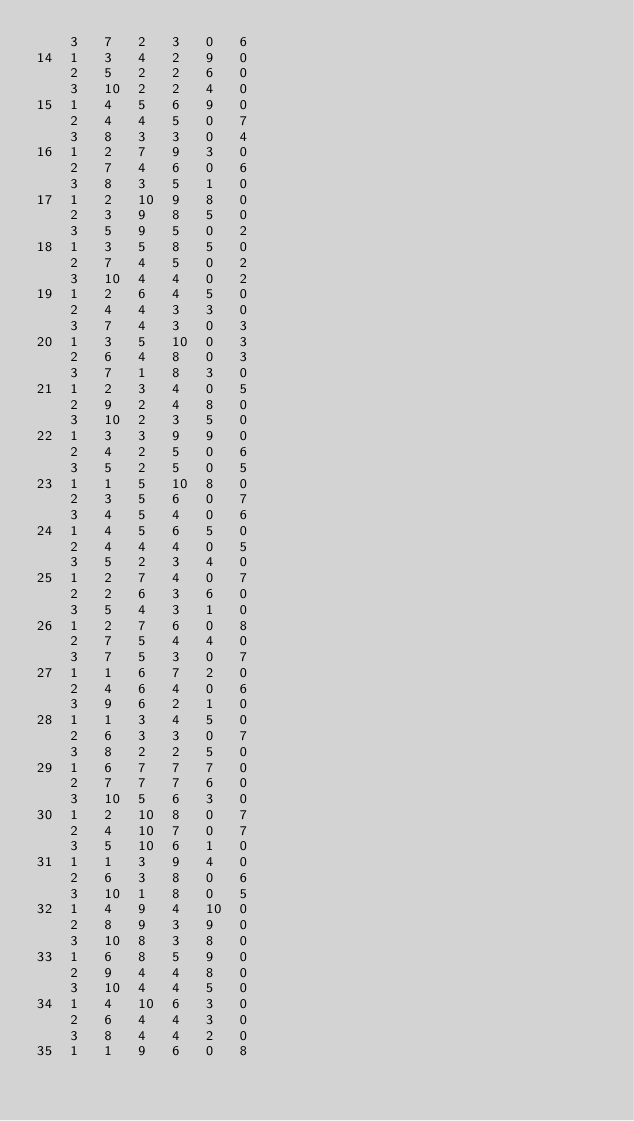<code> <loc_0><loc_0><loc_500><loc_500><_ObjectiveC_>	3	7	2	3	0	6	
14	1	3	4	2	9	0	
	2	5	2	2	6	0	
	3	10	2	2	4	0	
15	1	4	5	6	9	0	
	2	4	4	5	0	7	
	3	8	3	3	0	4	
16	1	2	7	9	3	0	
	2	7	4	6	0	6	
	3	8	3	5	1	0	
17	1	2	10	9	8	0	
	2	3	9	8	5	0	
	3	5	9	5	0	2	
18	1	3	5	8	5	0	
	2	7	4	5	0	2	
	3	10	4	4	0	2	
19	1	2	6	4	5	0	
	2	4	4	3	3	0	
	3	7	4	3	0	3	
20	1	3	5	10	0	3	
	2	6	4	8	0	3	
	3	7	1	8	3	0	
21	1	2	3	4	0	5	
	2	9	2	4	8	0	
	3	10	2	3	5	0	
22	1	3	3	9	9	0	
	2	4	2	5	0	6	
	3	5	2	5	0	5	
23	1	1	5	10	8	0	
	2	3	5	6	0	7	
	3	4	5	4	0	6	
24	1	4	5	6	5	0	
	2	4	4	4	0	5	
	3	5	2	3	4	0	
25	1	2	7	4	0	7	
	2	2	6	3	6	0	
	3	5	4	3	1	0	
26	1	2	7	6	0	8	
	2	7	5	4	4	0	
	3	7	5	3	0	7	
27	1	1	6	7	2	0	
	2	4	6	4	0	6	
	3	9	6	2	1	0	
28	1	1	3	4	5	0	
	2	6	3	3	0	7	
	3	8	2	2	5	0	
29	1	6	7	7	7	0	
	2	7	7	7	6	0	
	3	10	5	6	3	0	
30	1	2	10	8	0	7	
	2	4	10	7	0	7	
	3	5	10	6	1	0	
31	1	1	3	9	4	0	
	2	6	3	8	0	6	
	3	10	1	8	0	5	
32	1	4	9	4	10	0	
	2	8	9	3	9	0	
	3	10	8	3	8	0	
33	1	6	8	5	9	0	
	2	9	4	4	8	0	
	3	10	4	4	5	0	
34	1	4	10	6	3	0	
	2	6	4	4	3	0	
	3	8	4	4	2	0	
35	1	1	9	6	0	8	</code> 